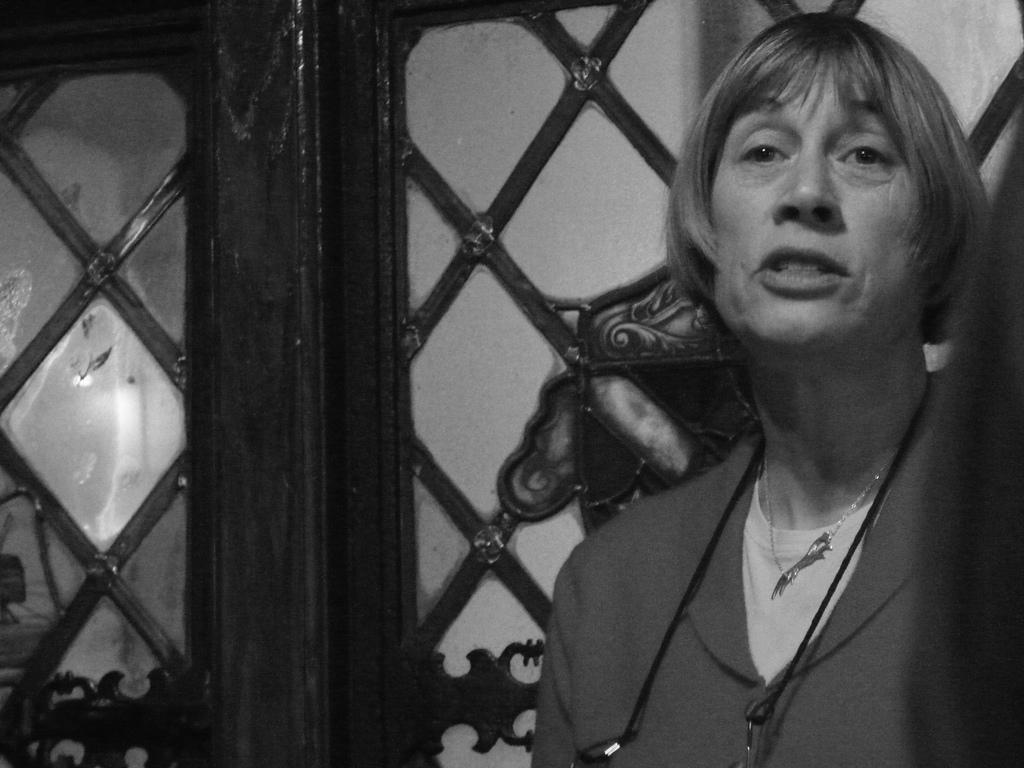What is the color scheme of the image? The image is black and white. Can you describe the person on the right side of the image? There is a person in a different costume on the right side of the image. What can be seen in the background of the image? There is a door in the background of the image. Is there a feeling of water in the image? There is no mention of water or any feeling associated with it in the image. 